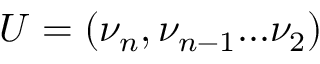<formula> <loc_0><loc_0><loc_500><loc_500>U = ( \nu _ { n } , \nu _ { n - 1 } \dots \nu _ { 2 } )</formula> 